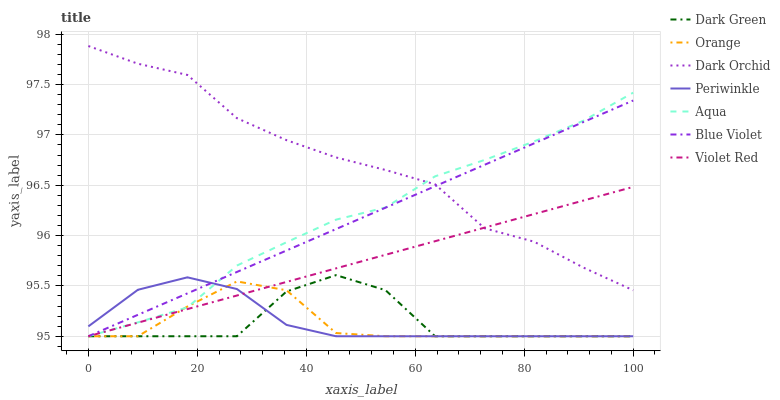Does Orange have the minimum area under the curve?
Answer yes or no. Yes. Does Dark Orchid have the maximum area under the curve?
Answer yes or no. Yes. Does Aqua have the minimum area under the curve?
Answer yes or no. No. Does Aqua have the maximum area under the curve?
Answer yes or no. No. Is Blue Violet the smoothest?
Answer yes or no. Yes. Is Dark Green the roughest?
Answer yes or no. Yes. Is Aqua the smoothest?
Answer yes or no. No. Is Aqua the roughest?
Answer yes or no. No. Does Dark Orchid have the lowest value?
Answer yes or no. No. Does Dark Orchid have the highest value?
Answer yes or no. Yes. Does Aqua have the highest value?
Answer yes or no. No. Is Periwinkle less than Dark Orchid?
Answer yes or no. Yes. Is Dark Orchid greater than Orange?
Answer yes or no. Yes. Does Orange intersect Periwinkle?
Answer yes or no. Yes. Is Orange less than Periwinkle?
Answer yes or no. No. Is Orange greater than Periwinkle?
Answer yes or no. No. Does Periwinkle intersect Dark Orchid?
Answer yes or no. No. 